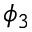<formula> <loc_0><loc_0><loc_500><loc_500>\phi _ { 3 }</formula> 